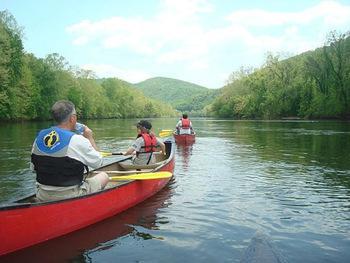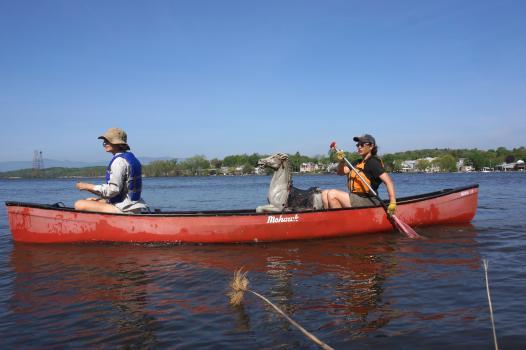The first image is the image on the left, the second image is the image on the right. For the images displayed, is the sentence "In each picture on the right, there are 3 people in a red canoe." factually correct? Answer yes or no. No. 